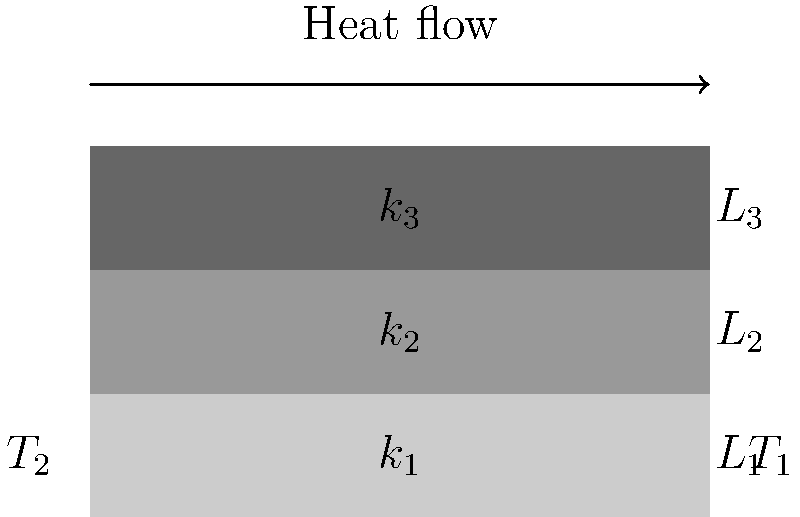A multi-layered composite material consists of three layers with thicknesses $L_1 = 2$ cm, $L_2 = 3$ cm, and $L_3 = 1$ cm, and thermal conductivities $k_1 = 15$ W/(m·K), $k_2 = 5$ W/(m·K), and $k_3 = 10$ W/(m·K), respectively. If the temperature difference between the two sides of the composite is 100°C, what is the heat flux through the material in W/m²? To solve this problem, we'll follow these steps:

1) First, we need to calculate the total thermal resistance of the composite. The thermal resistance of each layer is given by $R_i = \frac{L_i}{k_i}$, where $L_i$ is the thickness and $k_i$ is the thermal conductivity.

2) For the first layer: $R_1 = \frac{0.02 \text{ m}}{15 \text{ W/(m·K)}} = 0.00133 \text{ m²K/W}$

3) For the second layer: $R_2 = \frac{0.03 \text{ m}}{5 \text{ W/(m·K)}} = 0.006 \text{ m²K/W}$

4) For the third layer: $R_3 = \frac{0.01 \text{ m}}{10 \text{ W/(m·K)}} = 0.001 \text{ m²K/W}$

5) The total thermal resistance is the sum of these individual resistances:
   $R_{\text{total}} = R_1 + R_2 + R_3 = 0.00133 + 0.006 + 0.001 = 0.00833 \text{ m²K/W}$

6) Now we can use Fourier's law of heat conduction to calculate the heat flux:
   $q = \frac{\Delta T}{R_{\text{total}}}$

   Where $q$ is the heat flux and $\Delta T$ is the temperature difference.

7) Plugging in the values:
   $q = \frac{100 \text{ K}}{0.00833 \text{ m²K/W}} = 12,005 \text{ W/m²}$

Thus, the heat flux through the composite material is approximately 12,005 W/m².
Answer: 12,005 W/m² 